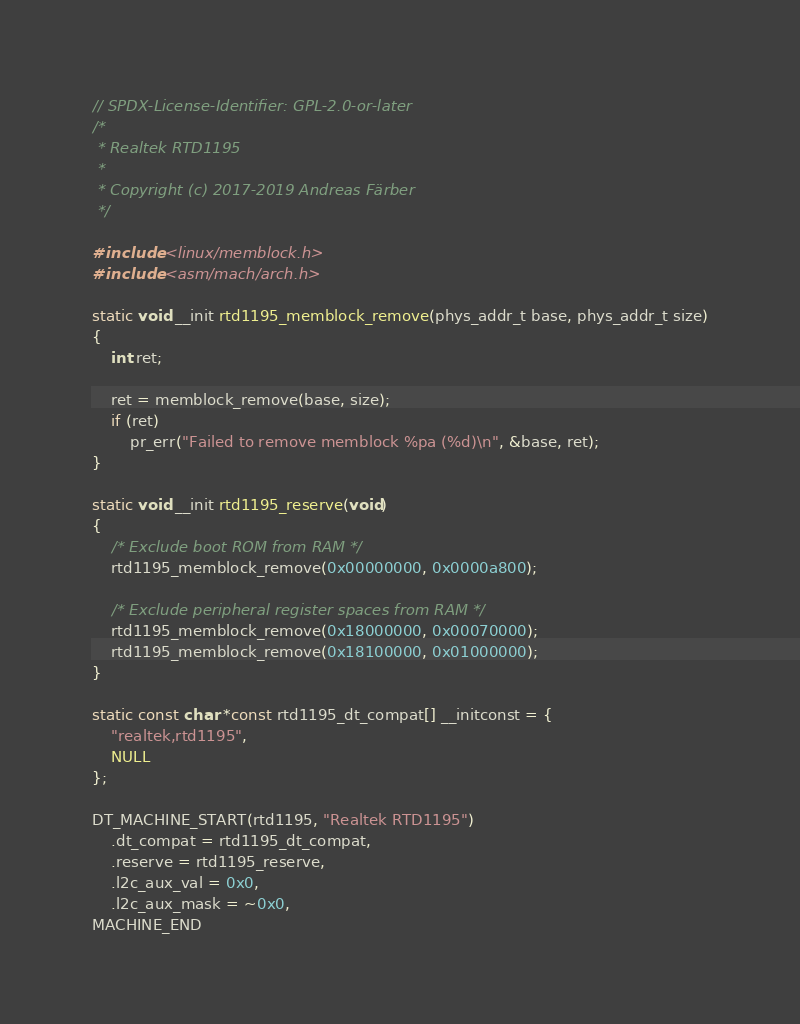Convert code to text. <code><loc_0><loc_0><loc_500><loc_500><_C_>// SPDX-License-Identifier: GPL-2.0-or-later
/*
 * Realtek RTD1195
 *
 * Copyright (c) 2017-2019 Andreas Färber
 */

#include <linux/memblock.h>
#include <asm/mach/arch.h>

static void __init rtd1195_memblock_remove(phys_addr_t base, phys_addr_t size)
{
	int ret;

	ret = memblock_remove(base, size);
	if (ret)
		pr_err("Failed to remove memblock %pa (%d)\n", &base, ret);
}

static void __init rtd1195_reserve(void)
{
	/* Exclude boot ROM from RAM */
	rtd1195_memblock_remove(0x00000000, 0x0000a800);

	/* Exclude peripheral register spaces from RAM */
	rtd1195_memblock_remove(0x18000000, 0x00070000);
	rtd1195_memblock_remove(0x18100000, 0x01000000);
}

static const char *const rtd1195_dt_compat[] __initconst = {
	"realtek,rtd1195",
	NULL
};

DT_MACHINE_START(rtd1195, "Realtek RTD1195")
	.dt_compat = rtd1195_dt_compat,
	.reserve = rtd1195_reserve,
	.l2c_aux_val = 0x0,
	.l2c_aux_mask = ~0x0,
MACHINE_END
</code> 